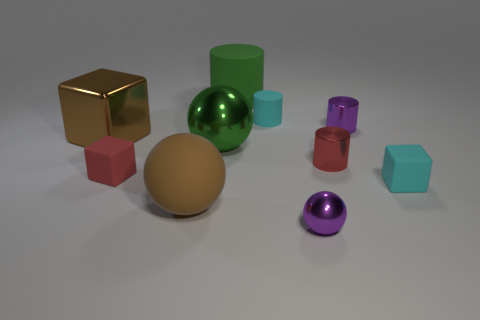There is a tiny cyan object in front of the tiny cyan matte cylinder; does it have the same shape as the tiny red rubber object?
Your answer should be compact. Yes. There is a block that is the same color as the large matte sphere; what size is it?
Provide a short and direct response. Large. Is there a purple sphere that has the same size as the cyan cube?
Provide a short and direct response. Yes. Is there a tiny red thing to the right of the big thing behind the cyan cylinder that is behind the big brown sphere?
Offer a terse response. Yes. There is a small sphere; does it have the same color as the tiny metallic cylinder that is behind the large green metal ball?
Your response must be concise. Yes. The cube right of the tiny purple metallic object that is in front of the cube that is behind the red cylinder is made of what material?
Offer a terse response. Rubber. What shape is the cyan matte object that is behind the red shiny object?
Your response must be concise. Cylinder. What is the size of the block that is the same material as the tiny purple cylinder?
Give a very brief answer. Large. What number of small purple shiny things have the same shape as the brown matte object?
Ensure brevity in your answer.  1. Is the color of the big matte cylinder that is behind the big rubber ball the same as the big metallic ball?
Ensure brevity in your answer.  Yes. 